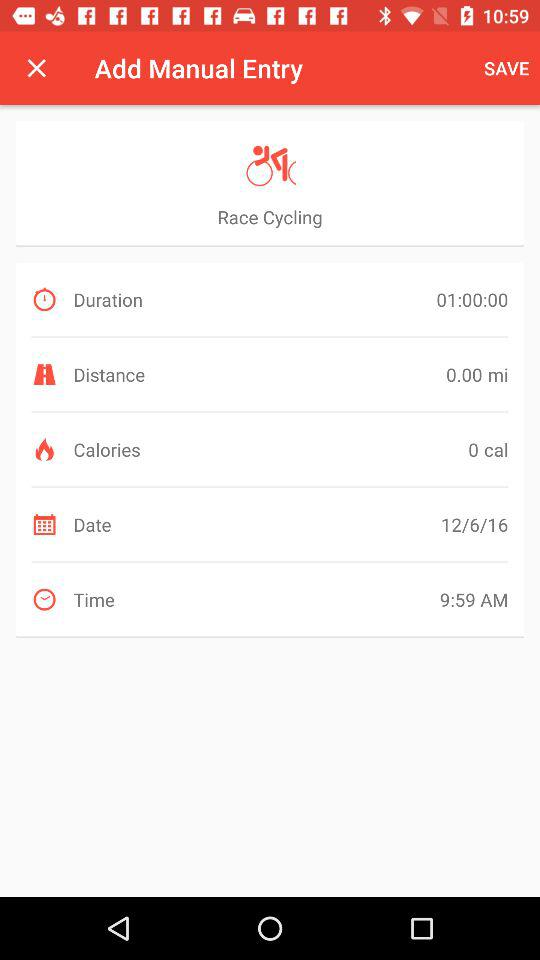What is the mentioned date? The mentioned date is June 12, 2016. 